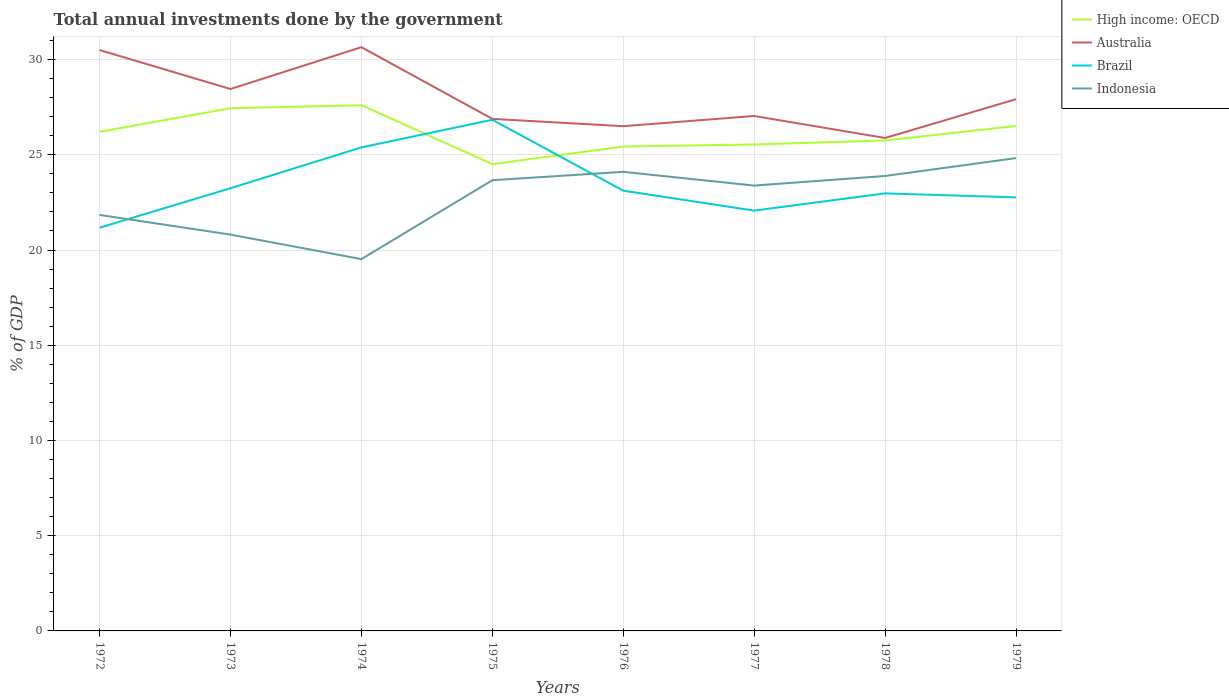How many different coloured lines are there?
Your answer should be compact. 4. Across all years, what is the maximum total annual investments done by the government in Indonesia?
Ensure brevity in your answer.  19.52. In which year was the total annual investments done by the government in High income: OECD maximum?
Provide a short and direct response. 1975. What is the total total annual investments done by the government in Australia in the graph?
Ensure brevity in your answer.  -2.2. What is the difference between the highest and the second highest total annual investments done by the government in Indonesia?
Provide a succinct answer. 5.3. Is the total annual investments done by the government in Australia strictly greater than the total annual investments done by the government in Indonesia over the years?
Your answer should be very brief. No. How many lines are there?
Offer a terse response. 4. What is the difference between two consecutive major ticks on the Y-axis?
Ensure brevity in your answer.  5. Does the graph contain grids?
Give a very brief answer. Yes. How many legend labels are there?
Offer a terse response. 4. How are the legend labels stacked?
Provide a succinct answer. Vertical. What is the title of the graph?
Your response must be concise. Total annual investments done by the government. What is the label or title of the Y-axis?
Give a very brief answer. % of GDP. What is the % of GDP of High income: OECD in 1972?
Keep it short and to the point. 26.21. What is the % of GDP in Australia in 1972?
Ensure brevity in your answer.  30.5. What is the % of GDP in Brazil in 1972?
Provide a short and direct response. 21.17. What is the % of GDP of Indonesia in 1972?
Your answer should be compact. 21.84. What is the % of GDP in High income: OECD in 1973?
Keep it short and to the point. 27.45. What is the % of GDP in Australia in 1973?
Give a very brief answer. 28.45. What is the % of GDP of Brazil in 1973?
Your response must be concise. 23.24. What is the % of GDP in Indonesia in 1973?
Ensure brevity in your answer.  20.81. What is the % of GDP of High income: OECD in 1974?
Offer a very short reply. 27.6. What is the % of GDP in Australia in 1974?
Ensure brevity in your answer.  30.65. What is the % of GDP in Brazil in 1974?
Your answer should be compact. 25.39. What is the % of GDP of Indonesia in 1974?
Make the answer very short. 19.52. What is the % of GDP in High income: OECD in 1975?
Give a very brief answer. 24.51. What is the % of GDP in Australia in 1975?
Provide a succinct answer. 26.89. What is the % of GDP in Brazil in 1975?
Keep it short and to the point. 26.84. What is the % of GDP of Indonesia in 1975?
Keep it short and to the point. 23.66. What is the % of GDP of High income: OECD in 1976?
Your response must be concise. 25.43. What is the % of GDP in Australia in 1976?
Give a very brief answer. 26.5. What is the % of GDP of Brazil in 1976?
Make the answer very short. 23.12. What is the % of GDP in Indonesia in 1976?
Your response must be concise. 24.1. What is the % of GDP in High income: OECD in 1977?
Provide a succinct answer. 25.54. What is the % of GDP in Australia in 1977?
Your response must be concise. 27.04. What is the % of GDP of Brazil in 1977?
Your answer should be very brief. 22.07. What is the % of GDP of Indonesia in 1977?
Offer a terse response. 23.38. What is the % of GDP of High income: OECD in 1978?
Give a very brief answer. 25.75. What is the % of GDP in Australia in 1978?
Keep it short and to the point. 25.88. What is the % of GDP in Brazil in 1978?
Give a very brief answer. 22.97. What is the % of GDP in Indonesia in 1978?
Offer a very short reply. 23.89. What is the % of GDP of High income: OECD in 1979?
Give a very brief answer. 26.51. What is the % of GDP of Australia in 1979?
Ensure brevity in your answer.  27.92. What is the % of GDP in Brazil in 1979?
Offer a terse response. 22.76. What is the % of GDP in Indonesia in 1979?
Provide a short and direct response. 24.83. Across all years, what is the maximum % of GDP of High income: OECD?
Keep it short and to the point. 27.6. Across all years, what is the maximum % of GDP of Australia?
Keep it short and to the point. 30.65. Across all years, what is the maximum % of GDP in Brazil?
Your response must be concise. 26.84. Across all years, what is the maximum % of GDP of Indonesia?
Your response must be concise. 24.83. Across all years, what is the minimum % of GDP in High income: OECD?
Your answer should be very brief. 24.51. Across all years, what is the minimum % of GDP in Australia?
Provide a succinct answer. 25.88. Across all years, what is the minimum % of GDP of Brazil?
Your response must be concise. 21.17. Across all years, what is the minimum % of GDP of Indonesia?
Your answer should be compact. 19.52. What is the total % of GDP of High income: OECD in the graph?
Your response must be concise. 209.01. What is the total % of GDP in Australia in the graph?
Offer a very short reply. 223.83. What is the total % of GDP of Brazil in the graph?
Ensure brevity in your answer.  187.57. What is the total % of GDP of Indonesia in the graph?
Make the answer very short. 182.04. What is the difference between the % of GDP of High income: OECD in 1972 and that in 1973?
Provide a succinct answer. -1.24. What is the difference between the % of GDP of Australia in 1972 and that in 1973?
Provide a succinct answer. 2.05. What is the difference between the % of GDP in Brazil in 1972 and that in 1973?
Ensure brevity in your answer.  -2.07. What is the difference between the % of GDP in Indonesia in 1972 and that in 1973?
Provide a succinct answer. 1.03. What is the difference between the % of GDP in High income: OECD in 1972 and that in 1974?
Ensure brevity in your answer.  -1.39. What is the difference between the % of GDP in Australia in 1972 and that in 1974?
Offer a very short reply. -0.15. What is the difference between the % of GDP of Brazil in 1972 and that in 1974?
Make the answer very short. -4.22. What is the difference between the % of GDP of Indonesia in 1972 and that in 1974?
Your response must be concise. 2.32. What is the difference between the % of GDP of High income: OECD in 1972 and that in 1975?
Provide a short and direct response. 1.7. What is the difference between the % of GDP of Australia in 1972 and that in 1975?
Your response must be concise. 3.62. What is the difference between the % of GDP in Brazil in 1972 and that in 1975?
Give a very brief answer. -5.67. What is the difference between the % of GDP of Indonesia in 1972 and that in 1975?
Offer a terse response. -1.82. What is the difference between the % of GDP in High income: OECD in 1972 and that in 1976?
Your answer should be compact. 0.77. What is the difference between the % of GDP of Australia in 1972 and that in 1976?
Your answer should be compact. 4. What is the difference between the % of GDP in Brazil in 1972 and that in 1976?
Provide a short and direct response. -1.95. What is the difference between the % of GDP in Indonesia in 1972 and that in 1976?
Keep it short and to the point. -2.26. What is the difference between the % of GDP in High income: OECD in 1972 and that in 1977?
Keep it short and to the point. 0.67. What is the difference between the % of GDP of Australia in 1972 and that in 1977?
Your answer should be very brief. 3.46. What is the difference between the % of GDP of Brazil in 1972 and that in 1977?
Your answer should be compact. -0.9. What is the difference between the % of GDP in Indonesia in 1972 and that in 1977?
Give a very brief answer. -1.54. What is the difference between the % of GDP in High income: OECD in 1972 and that in 1978?
Provide a short and direct response. 0.46. What is the difference between the % of GDP of Australia in 1972 and that in 1978?
Provide a short and direct response. 4.62. What is the difference between the % of GDP of Brazil in 1972 and that in 1978?
Keep it short and to the point. -1.8. What is the difference between the % of GDP in Indonesia in 1972 and that in 1978?
Your answer should be compact. -2.05. What is the difference between the % of GDP in High income: OECD in 1972 and that in 1979?
Ensure brevity in your answer.  -0.31. What is the difference between the % of GDP of Australia in 1972 and that in 1979?
Offer a terse response. 2.58. What is the difference between the % of GDP of Brazil in 1972 and that in 1979?
Offer a very short reply. -1.59. What is the difference between the % of GDP in Indonesia in 1972 and that in 1979?
Make the answer very short. -2.98. What is the difference between the % of GDP of High income: OECD in 1973 and that in 1974?
Offer a very short reply. -0.16. What is the difference between the % of GDP in Australia in 1973 and that in 1974?
Your response must be concise. -2.2. What is the difference between the % of GDP of Brazil in 1973 and that in 1974?
Offer a very short reply. -2.14. What is the difference between the % of GDP of Indonesia in 1973 and that in 1974?
Your answer should be compact. 1.29. What is the difference between the % of GDP in High income: OECD in 1973 and that in 1975?
Offer a very short reply. 2.94. What is the difference between the % of GDP of Australia in 1973 and that in 1975?
Offer a very short reply. 1.57. What is the difference between the % of GDP of Brazil in 1973 and that in 1975?
Offer a very short reply. -3.59. What is the difference between the % of GDP of Indonesia in 1973 and that in 1975?
Keep it short and to the point. -2.86. What is the difference between the % of GDP of High income: OECD in 1973 and that in 1976?
Your answer should be very brief. 2.01. What is the difference between the % of GDP of Australia in 1973 and that in 1976?
Offer a very short reply. 1.95. What is the difference between the % of GDP in Brazil in 1973 and that in 1976?
Provide a succinct answer. 0.13. What is the difference between the % of GDP in Indonesia in 1973 and that in 1976?
Give a very brief answer. -3.3. What is the difference between the % of GDP of High income: OECD in 1973 and that in 1977?
Your answer should be very brief. 1.91. What is the difference between the % of GDP of Australia in 1973 and that in 1977?
Your answer should be very brief. 1.42. What is the difference between the % of GDP in Brazil in 1973 and that in 1977?
Your response must be concise. 1.17. What is the difference between the % of GDP of Indonesia in 1973 and that in 1977?
Your answer should be very brief. -2.58. What is the difference between the % of GDP in High income: OECD in 1973 and that in 1978?
Offer a terse response. 1.69. What is the difference between the % of GDP of Australia in 1973 and that in 1978?
Keep it short and to the point. 2.57. What is the difference between the % of GDP in Brazil in 1973 and that in 1978?
Ensure brevity in your answer.  0.27. What is the difference between the % of GDP in Indonesia in 1973 and that in 1978?
Your response must be concise. -3.08. What is the difference between the % of GDP in High income: OECD in 1973 and that in 1979?
Ensure brevity in your answer.  0.93. What is the difference between the % of GDP in Australia in 1973 and that in 1979?
Your response must be concise. 0.53. What is the difference between the % of GDP in Brazil in 1973 and that in 1979?
Your answer should be compact. 0.48. What is the difference between the % of GDP of Indonesia in 1973 and that in 1979?
Give a very brief answer. -4.02. What is the difference between the % of GDP in High income: OECD in 1974 and that in 1975?
Give a very brief answer. 3.09. What is the difference between the % of GDP of Australia in 1974 and that in 1975?
Keep it short and to the point. 3.76. What is the difference between the % of GDP in Brazil in 1974 and that in 1975?
Your answer should be very brief. -1.45. What is the difference between the % of GDP of Indonesia in 1974 and that in 1975?
Offer a terse response. -4.14. What is the difference between the % of GDP of High income: OECD in 1974 and that in 1976?
Keep it short and to the point. 2.17. What is the difference between the % of GDP of Australia in 1974 and that in 1976?
Keep it short and to the point. 4.15. What is the difference between the % of GDP in Brazil in 1974 and that in 1976?
Offer a terse response. 2.27. What is the difference between the % of GDP in Indonesia in 1974 and that in 1976?
Offer a terse response. -4.58. What is the difference between the % of GDP of High income: OECD in 1974 and that in 1977?
Make the answer very short. 2.06. What is the difference between the % of GDP in Australia in 1974 and that in 1977?
Provide a short and direct response. 3.61. What is the difference between the % of GDP in Brazil in 1974 and that in 1977?
Your answer should be very brief. 3.32. What is the difference between the % of GDP of Indonesia in 1974 and that in 1977?
Provide a succinct answer. -3.86. What is the difference between the % of GDP in High income: OECD in 1974 and that in 1978?
Your answer should be compact. 1.85. What is the difference between the % of GDP in Australia in 1974 and that in 1978?
Offer a terse response. 4.77. What is the difference between the % of GDP of Brazil in 1974 and that in 1978?
Your response must be concise. 2.42. What is the difference between the % of GDP in Indonesia in 1974 and that in 1978?
Provide a succinct answer. -4.37. What is the difference between the % of GDP in High income: OECD in 1974 and that in 1979?
Offer a terse response. 1.09. What is the difference between the % of GDP of Australia in 1974 and that in 1979?
Your answer should be very brief. 2.73. What is the difference between the % of GDP in Brazil in 1974 and that in 1979?
Make the answer very short. 2.62. What is the difference between the % of GDP in Indonesia in 1974 and that in 1979?
Provide a succinct answer. -5.3. What is the difference between the % of GDP of High income: OECD in 1975 and that in 1976?
Your answer should be very brief. -0.93. What is the difference between the % of GDP in Australia in 1975 and that in 1976?
Keep it short and to the point. 0.38. What is the difference between the % of GDP in Brazil in 1975 and that in 1976?
Your answer should be compact. 3.72. What is the difference between the % of GDP in Indonesia in 1975 and that in 1976?
Offer a terse response. -0.44. What is the difference between the % of GDP in High income: OECD in 1975 and that in 1977?
Provide a succinct answer. -1.03. What is the difference between the % of GDP in Australia in 1975 and that in 1977?
Provide a succinct answer. -0.15. What is the difference between the % of GDP in Brazil in 1975 and that in 1977?
Your answer should be compact. 4.77. What is the difference between the % of GDP in Indonesia in 1975 and that in 1977?
Make the answer very short. 0.28. What is the difference between the % of GDP of High income: OECD in 1975 and that in 1978?
Ensure brevity in your answer.  -1.24. What is the difference between the % of GDP of Australia in 1975 and that in 1978?
Offer a terse response. 1. What is the difference between the % of GDP in Brazil in 1975 and that in 1978?
Your answer should be very brief. 3.87. What is the difference between the % of GDP in Indonesia in 1975 and that in 1978?
Your answer should be compact. -0.22. What is the difference between the % of GDP in High income: OECD in 1975 and that in 1979?
Make the answer very short. -2.01. What is the difference between the % of GDP in Australia in 1975 and that in 1979?
Offer a terse response. -1.03. What is the difference between the % of GDP in Brazil in 1975 and that in 1979?
Your answer should be compact. 4.07. What is the difference between the % of GDP of Indonesia in 1975 and that in 1979?
Keep it short and to the point. -1.16. What is the difference between the % of GDP of High income: OECD in 1976 and that in 1977?
Provide a short and direct response. -0.11. What is the difference between the % of GDP in Australia in 1976 and that in 1977?
Keep it short and to the point. -0.54. What is the difference between the % of GDP of Brazil in 1976 and that in 1977?
Keep it short and to the point. 1.05. What is the difference between the % of GDP in Indonesia in 1976 and that in 1977?
Give a very brief answer. 0.72. What is the difference between the % of GDP of High income: OECD in 1976 and that in 1978?
Give a very brief answer. -0.32. What is the difference between the % of GDP of Australia in 1976 and that in 1978?
Offer a terse response. 0.62. What is the difference between the % of GDP of Brazil in 1976 and that in 1978?
Your response must be concise. 0.14. What is the difference between the % of GDP of Indonesia in 1976 and that in 1978?
Offer a terse response. 0.22. What is the difference between the % of GDP in High income: OECD in 1976 and that in 1979?
Keep it short and to the point. -1.08. What is the difference between the % of GDP of Australia in 1976 and that in 1979?
Offer a terse response. -1.42. What is the difference between the % of GDP of Brazil in 1976 and that in 1979?
Provide a succinct answer. 0.35. What is the difference between the % of GDP in Indonesia in 1976 and that in 1979?
Keep it short and to the point. -0.72. What is the difference between the % of GDP of High income: OECD in 1977 and that in 1978?
Your answer should be very brief. -0.21. What is the difference between the % of GDP of Australia in 1977 and that in 1978?
Keep it short and to the point. 1.15. What is the difference between the % of GDP of Brazil in 1977 and that in 1978?
Offer a very short reply. -0.9. What is the difference between the % of GDP of Indonesia in 1977 and that in 1978?
Provide a succinct answer. -0.5. What is the difference between the % of GDP of High income: OECD in 1977 and that in 1979?
Keep it short and to the point. -0.97. What is the difference between the % of GDP in Australia in 1977 and that in 1979?
Provide a succinct answer. -0.88. What is the difference between the % of GDP of Brazil in 1977 and that in 1979?
Make the answer very short. -0.7. What is the difference between the % of GDP in Indonesia in 1977 and that in 1979?
Offer a terse response. -1.44. What is the difference between the % of GDP in High income: OECD in 1978 and that in 1979?
Offer a very short reply. -0.76. What is the difference between the % of GDP of Australia in 1978 and that in 1979?
Offer a very short reply. -2.04. What is the difference between the % of GDP of Brazil in 1978 and that in 1979?
Your answer should be compact. 0.21. What is the difference between the % of GDP in Indonesia in 1978 and that in 1979?
Give a very brief answer. -0.94. What is the difference between the % of GDP in High income: OECD in 1972 and the % of GDP in Australia in 1973?
Your answer should be compact. -2.24. What is the difference between the % of GDP in High income: OECD in 1972 and the % of GDP in Brazil in 1973?
Keep it short and to the point. 2.96. What is the difference between the % of GDP of High income: OECD in 1972 and the % of GDP of Indonesia in 1973?
Provide a succinct answer. 5.4. What is the difference between the % of GDP of Australia in 1972 and the % of GDP of Brazil in 1973?
Provide a succinct answer. 7.26. What is the difference between the % of GDP in Australia in 1972 and the % of GDP in Indonesia in 1973?
Provide a succinct answer. 9.69. What is the difference between the % of GDP of Brazil in 1972 and the % of GDP of Indonesia in 1973?
Offer a terse response. 0.36. What is the difference between the % of GDP of High income: OECD in 1972 and the % of GDP of Australia in 1974?
Your response must be concise. -4.44. What is the difference between the % of GDP of High income: OECD in 1972 and the % of GDP of Brazil in 1974?
Provide a short and direct response. 0.82. What is the difference between the % of GDP of High income: OECD in 1972 and the % of GDP of Indonesia in 1974?
Your answer should be very brief. 6.69. What is the difference between the % of GDP in Australia in 1972 and the % of GDP in Brazil in 1974?
Make the answer very short. 5.11. What is the difference between the % of GDP in Australia in 1972 and the % of GDP in Indonesia in 1974?
Offer a very short reply. 10.98. What is the difference between the % of GDP of Brazil in 1972 and the % of GDP of Indonesia in 1974?
Offer a terse response. 1.65. What is the difference between the % of GDP of High income: OECD in 1972 and the % of GDP of Australia in 1975?
Your answer should be very brief. -0.68. What is the difference between the % of GDP in High income: OECD in 1972 and the % of GDP in Brazil in 1975?
Provide a short and direct response. -0.63. What is the difference between the % of GDP of High income: OECD in 1972 and the % of GDP of Indonesia in 1975?
Offer a very short reply. 2.54. What is the difference between the % of GDP of Australia in 1972 and the % of GDP of Brazil in 1975?
Provide a succinct answer. 3.66. What is the difference between the % of GDP in Australia in 1972 and the % of GDP in Indonesia in 1975?
Ensure brevity in your answer.  6.84. What is the difference between the % of GDP of Brazil in 1972 and the % of GDP of Indonesia in 1975?
Your response must be concise. -2.49. What is the difference between the % of GDP in High income: OECD in 1972 and the % of GDP in Australia in 1976?
Give a very brief answer. -0.29. What is the difference between the % of GDP of High income: OECD in 1972 and the % of GDP of Brazil in 1976?
Offer a very short reply. 3.09. What is the difference between the % of GDP of High income: OECD in 1972 and the % of GDP of Indonesia in 1976?
Give a very brief answer. 2.1. What is the difference between the % of GDP in Australia in 1972 and the % of GDP in Brazil in 1976?
Your answer should be compact. 7.38. What is the difference between the % of GDP in Australia in 1972 and the % of GDP in Indonesia in 1976?
Make the answer very short. 6.4. What is the difference between the % of GDP in Brazil in 1972 and the % of GDP in Indonesia in 1976?
Keep it short and to the point. -2.93. What is the difference between the % of GDP in High income: OECD in 1972 and the % of GDP in Australia in 1977?
Keep it short and to the point. -0.83. What is the difference between the % of GDP in High income: OECD in 1972 and the % of GDP in Brazil in 1977?
Your answer should be compact. 4.14. What is the difference between the % of GDP of High income: OECD in 1972 and the % of GDP of Indonesia in 1977?
Ensure brevity in your answer.  2.83. What is the difference between the % of GDP in Australia in 1972 and the % of GDP in Brazil in 1977?
Your answer should be compact. 8.43. What is the difference between the % of GDP in Australia in 1972 and the % of GDP in Indonesia in 1977?
Offer a terse response. 7.12. What is the difference between the % of GDP of Brazil in 1972 and the % of GDP of Indonesia in 1977?
Your response must be concise. -2.21. What is the difference between the % of GDP of High income: OECD in 1972 and the % of GDP of Australia in 1978?
Give a very brief answer. 0.33. What is the difference between the % of GDP of High income: OECD in 1972 and the % of GDP of Brazil in 1978?
Give a very brief answer. 3.24. What is the difference between the % of GDP in High income: OECD in 1972 and the % of GDP in Indonesia in 1978?
Your answer should be compact. 2.32. What is the difference between the % of GDP of Australia in 1972 and the % of GDP of Brazil in 1978?
Keep it short and to the point. 7.53. What is the difference between the % of GDP of Australia in 1972 and the % of GDP of Indonesia in 1978?
Provide a short and direct response. 6.61. What is the difference between the % of GDP of Brazil in 1972 and the % of GDP of Indonesia in 1978?
Your answer should be very brief. -2.72. What is the difference between the % of GDP of High income: OECD in 1972 and the % of GDP of Australia in 1979?
Ensure brevity in your answer.  -1.71. What is the difference between the % of GDP of High income: OECD in 1972 and the % of GDP of Brazil in 1979?
Your answer should be compact. 3.44. What is the difference between the % of GDP of High income: OECD in 1972 and the % of GDP of Indonesia in 1979?
Provide a short and direct response. 1.38. What is the difference between the % of GDP of Australia in 1972 and the % of GDP of Brazil in 1979?
Offer a very short reply. 7.74. What is the difference between the % of GDP in Australia in 1972 and the % of GDP in Indonesia in 1979?
Provide a succinct answer. 5.67. What is the difference between the % of GDP of Brazil in 1972 and the % of GDP of Indonesia in 1979?
Your response must be concise. -3.66. What is the difference between the % of GDP of High income: OECD in 1973 and the % of GDP of Australia in 1974?
Ensure brevity in your answer.  -3.2. What is the difference between the % of GDP of High income: OECD in 1973 and the % of GDP of Brazil in 1974?
Offer a very short reply. 2.06. What is the difference between the % of GDP in High income: OECD in 1973 and the % of GDP in Indonesia in 1974?
Your answer should be compact. 7.93. What is the difference between the % of GDP of Australia in 1973 and the % of GDP of Brazil in 1974?
Make the answer very short. 3.06. What is the difference between the % of GDP in Australia in 1973 and the % of GDP in Indonesia in 1974?
Make the answer very short. 8.93. What is the difference between the % of GDP of Brazil in 1973 and the % of GDP of Indonesia in 1974?
Ensure brevity in your answer.  3.72. What is the difference between the % of GDP of High income: OECD in 1973 and the % of GDP of Australia in 1975?
Offer a very short reply. 0.56. What is the difference between the % of GDP of High income: OECD in 1973 and the % of GDP of Brazil in 1975?
Your answer should be very brief. 0.61. What is the difference between the % of GDP of High income: OECD in 1973 and the % of GDP of Indonesia in 1975?
Provide a short and direct response. 3.78. What is the difference between the % of GDP of Australia in 1973 and the % of GDP of Brazil in 1975?
Your answer should be very brief. 1.61. What is the difference between the % of GDP in Australia in 1973 and the % of GDP in Indonesia in 1975?
Provide a succinct answer. 4.79. What is the difference between the % of GDP of Brazil in 1973 and the % of GDP of Indonesia in 1975?
Your answer should be very brief. -0.42. What is the difference between the % of GDP in High income: OECD in 1973 and the % of GDP in Australia in 1976?
Ensure brevity in your answer.  0.95. What is the difference between the % of GDP in High income: OECD in 1973 and the % of GDP in Brazil in 1976?
Ensure brevity in your answer.  4.33. What is the difference between the % of GDP of High income: OECD in 1973 and the % of GDP of Indonesia in 1976?
Give a very brief answer. 3.34. What is the difference between the % of GDP of Australia in 1973 and the % of GDP of Brazil in 1976?
Your response must be concise. 5.34. What is the difference between the % of GDP of Australia in 1973 and the % of GDP of Indonesia in 1976?
Your response must be concise. 4.35. What is the difference between the % of GDP in Brazil in 1973 and the % of GDP in Indonesia in 1976?
Keep it short and to the point. -0.86. What is the difference between the % of GDP of High income: OECD in 1973 and the % of GDP of Australia in 1977?
Give a very brief answer. 0.41. What is the difference between the % of GDP in High income: OECD in 1973 and the % of GDP in Brazil in 1977?
Your answer should be compact. 5.38. What is the difference between the % of GDP in High income: OECD in 1973 and the % of GDP in Indonesia in 1977?
Provide a succinct answer. 4.06. What is the difference between the % of GDP in Australia in 1973 and the % of GDP in Brazil in 1977?
Your answer should be compact. 6.38. What is the difference between the % of GDP in Australia in 1973 and the % of GDP in Indonesia in 1977?
Provide a succinct answer. 5.07. What is the difference between the % of GDP in Brazil in 1973 and the % of GDP in Indonesia in 1977?
Keep it short and to the point. -0.14. What is the difference between the % of GDP of High income: OECD in 1973 and the % of GDP of Australia in 1978?
Offer a very short reply. 1.56. What is the difference between the % of GDP of High income: OECD in 1973 and the % of GDP of Brazil in 1978?
Provide a succinct answer. 4.47. What is the difference between the % of GDP in High income: OECD in 1973 and the % of GDP in Indonesia in 1978?
Keep it short and to the point. 3.56. What is the difference between the % of GDP of Australia in 1973 and the % of GDP of Brazil in 1978?
Provide a succinct answer. 5.48. What is the difference between the % of GDP in Australia in 1973 and the % of GDP in Indonesia in 1978?
Your response must be concise. 4.57. What is the difference between the % of GDP in Brazil in 1973 and the % of GDP in Indonesia in 1978?
Make the answer very short. -0.64. What is the difference between the % of GDP in High income: OECD in 1973 and the % of GDP in Australia in 1979?
Your answer should be very brief. -0.47. What is the difference between the % of GDP of High income: OECD in 1973 and the % of GDP of Brazil in 1979?
Provide a short and direct response. 4.68. What is the difference between the % of GDP in High income: OECD in 1973 and the % of GDP in Indonesia in 1979?
Give a very brief answer. 2.62. What is the difference between the % of GDP in Australia in 1973 and the % of GDP in Brazil in 1979?
Provide a short and direct response. 5.69. What is the difference between the % of GDP in Australia in 1973 and the % of GDP in Indonesia in 1979?
Make the answer very short. 3.63. What is the difference between the % of GDP in Brazil in 1973 and the % of GDP in Indonesia in 1979?
Offer a very short reply. -1.58. What is the difference between the % of GDP in High income: OECD in 1974 and the % of GDP in Australia in 1975?
Keep it short and to the point. 0.72. What is the difference between the % of GDP of High income: OECD in 1974 and the % of GDP of Brazil in 1975?
Your answer should be very brief. 0.76. What is the difference between the % of GDP of High income: OECD in 1974 and the % of GDP of Indonesia in 1975?
Provide a short and direct response. 3.94. What is the difference between the % of GDP of Australia in 1974 and the % of GDP of Brazil in 1975?
Your answer should be very brief. 3.81. What is the difference between the % of GDP of Australia in 1974 and the % of GDP of Indonesia in 1975?
Provide a succinct answer. 6.99. What is the difference between the % of GDP in Brazil in 1974 and the % of GDP in Indonesia in 1975?
Your answer should be compact. 1.72. What is the difference between the % of GDP of High income: OECD in 1974 and the % of GDP of Australia in 1976?
Provide a succinct answer. 1.1. What is the difference between the % of GDP in High income: OECD in 1974 and the % of GDP in Brazil in 1976?
Your answer should be compact. 4.49. What is the difference between the % of GDP in High income: OECD in 1974 and the % of GDP in Indonesia in 1976?
Your response must be concise. 3.5. What is the difference between the % of GDP in Australia in 1974 and the % of GDP in Brazil in 1976?
Provide a short and direct response. 7.53. What is the difference between the % of GDP in Australia in 1974 and the % of GDP in Indonesia in 1976?
Your answer should be very brief. 6.55. What is the difference between the % of GDP in Brazil in 1974 and the % of GDP in Indonesia in 1976?
Offer a terse response. 1.28. What is the difference between the % of GDP of High income: OECD in 1974 and the % of GDP of Australia in 1977?
Offer a terse response. 0.57. What is the difference between the % of GDP of High income: OECD in 1974 and the % of GDP of Brazil in 1977?
Provide a succinct answer. 5.53. What is the difference between the % of GDP in High income: OECD in 1974 and the % of GDP in Indonesia in 1977?
Your response must be concise. 4.22. What is the difference between the % of GDP in Australia in 1974 and the % of GDP in Brazil in 1977?
Give a very brief answer. 8.58. What is the difference between the % of GDP in Australia in 1974 and the % of GDP in Indonesia in 1977?
Make the answer very short. 7.27. What is the difference between the % of GDP in Brazil in 1974 and the % of GDP in Indonesia in 1977?
Give a very brief answer. 2. What is the difference between the % of GDP in High income: OECD in 1974 and the % of GDP in Australia in 1978?
Offer a terse response. 1.72. What is the difference between the % of GDP in High income: OECD in 1974 and the % of GDP in Brazil in 1978?
Ensure brevity in your answer.  4.63. What is the difference between the % of GDP in High income: OECD in 1974 and the % of GDP in Indonesia in 1978?
Give a very brief answer. 3.71. What is the difference between the % of GDP of Australia in 1974 and the % of GDP of Brazil in 1978?
Ensure brevity in your answer.  7.68. What is the difference between the % of GDP of Australia in 1974 and the % of GDP of Indonesia in 1978?
Your answer should be compact. 6.76. What is the difference between the % of GDP in Brazil in 1974 and the % of GDP in Indonesia in 1978?
Give a very brief answer. 1.5. What is the difference between the % of GDP in High income: OECD in 1974 and the % of GDP in Australia in 1979?
Provide a short and direct response. -0.32. What is the difference between the % of GDP in High income: OECD in 1974 and the % of GDP in Brazil in 1979?
Offer a very short reply. 4.84. What is the difference between the % of GDP in High income: OECD in 1974 and the % of GDP in Indonesia in 1979?
Make the answer very short. 2.78. What is the difference between the % of GDP in Australia in 1974 and the % of GDP in Brazil in 1979?
Your answer should be compact. 7.89. What is the difference between the % of GDP of Australia in 1974 and the % of GDP of Indonesia in 1979?
Offer a terse response. 5.82. What is the difference between the % of GDP of Brazil in 1974 and the % of GDP of Indonesia in 1979?
Make the answer very short. 0.56. What is the difference between the % of GDP of High income: OECD in 1975 and the % of GDP of Australia in 1976?
Provide a succinct answer. -1.99. What is the difference between the % of GDP of High income: OECD in 1975 and the % of GDP of Brazil in 1976?
Offer a very short reply. 1.39. What is the difference between the % of GDP of High income: OECD in 1975 and the % of GDP of Indonesia in 1976?
Ensure brevity in your answer.  0.4. What is the difference between the % of GDP in Australia in 1975 and the % of GDP in Brazil in 1976?
Make the answer very short. 3.77. What is the difference between the % of GDP of Australia in 1975 and the % of GDP of Indonesia in 1976?
Offer a terse response. 2.78. What is the difference between the % of GDP in Brazil in 1975 and the % of GDP in Indonesia in 1976?
Your response must be concise. 2.73. What is the difference between the % of GDP in High income: OECD in 1975 and the % of GDP in Australia in 1977?
Your answer should be very brief. -2.53. What is the difference between the % of GDP of High income: OECD in 1975 and the % of GDP of Brazil in 1977?
Provide a succinct answer. 2.44. What is the difference between the % of GDP of High income: OECD in 1975 and the % of GDP of Indonesia in 1977?
Keep it short and to the point. 1.12. What is the difference between the % of GDP of Australia in 1975 and the % of GDP of Brazil in 1977?
Offer a terse response. 4.82. What is the difference between the % of GDP of Australia in 1975 and the % of GDP of Indonesia in 1977?
Provide a succinct answer. 3.5. What is the difference between the % of GDP of Brazil in 1975 and the % of GDP of Indonesia in 1977?
Give a very brief answer. 3.46. What is the difference between the % of GDP in High income: OECD in 1975 and the % of GDP in Australia in 1978?
Give a very brief answer. -1.37. What is the difference between the % of GDP of High income: OECD in 1975 and the % of GDP of Brazil in 1978?
Offer a terse response. 1.53. What is the difference between the % of GDP of High income: OECD in 1975 and the % of GDP of Indonesia in 1978?
Your response must be concise. 0.62. What is the difference between the % of GDP in Australia in 1975 and the % of GDP in Brazil in 1978?
Ensure brevity in your answer.  3.91. What is the difference between the % of GDP of Australia in 1975 and the % of GDP of Indonesia in 1978?
Make the answer very short. 3. What is the difference between the % of GDP in Brazil in 1975 and the % of GDP in Indonesia in 1978?
Your response must be concise. 2.95. What is the difference between the % of GDP in High income: OECD in 1975 and the % of GDP in Australia in 1979?
Your response must be concise. -3.41. What is the difference between the % of GDP in High income: OECD in 1975 and the % of GDP in Brazil in 1979?
Provide a succinct answer. 1.74. What is the difference between the % of GDP in High income: OECD in 1975 and the % of GDP in Indonesia in 1979?
Ensure brevity in your answer.  -0.32. What is the difference between the % of GDP in Australia in 1975 and the % of GDP in Brazil in 1979?
Offer a very short reply. 4.12. What is the difference between the % of GDP of Australia in 1975 and the % of GDP of Indonesia in 1979?
Ensure brevity in your answer.  2.06. What is the difference between the % of GDP of Brazil in 1975 and the % of GDP of Indonesia in 1979?
Give a very brief answer. 2.01. What is the difference between the % of GDP in High income: OECD in 1976 and the % of GDP in Australia in 1977?
Your response must be concise. -1.6. What is the difference between the % of GDP of High income: OECD in 1976 and the % of GDP of Brazil in 1977?
Offer a terse response. 3.37. What is the difference between the % of GDP in High income: OECD in 1976 and the % of GDP in Indonesia in 1977?
Ensure brevity in your answer.  2.05. What is the difference between the % of GDP in Australia in 1976 and the % of GDP in Brazil in 1977?
Your response must be concise. 4.43. What is the difference between the % of GDP of Australia in 1976 and the % of GDP of Indonesia in 1977?
Offer a very short reply. 3.12. What is the difference between the % of GDP in Brazil in 1976 and the % of GDP in Indonesia in 1977?
Provide a succinct answer. -0.27. What is the difference between the % of GDP of High income: OECD in 1976 and the % of GDP of Australia in 1978?
Offer a very short reply. -0.45. What is the difference between the % of GDP of High income: OECD in 1976 and the % of GDP of Brazil in 1978?
Ensure brevity in your answer.  2.46. What is the difference between the % of GDP of High income: OECD in 1976 and the % of GDP of Indonesia in 1978?
Ensure brevity in your answer.  1.55. What is the difference between the % of GDP of Australia in 1976 and the % of GDP of Brazil in 1978?
Your answer should be compact. 3.53. What is the difference between the % of GDP of Australia in 1976 and the % of GDP of Indonesia in 1978?
Your answer should be very brief. 2.61. What is the difference between the % of GDP of Brazil in 1976 and the % of GDP of Indonesia in 1978?
Provide a succinct answer. -0.77. What is the difference between the % of GDP of High income: OECD in 1976 and the % of GDP of Australia in 1979?
Ensure brevity in your answer.  -2.49. What is the difference between the % of GDP of High income: OECD in 1976 and the % of GDP of Brazil in 1979?
Keep it short and to the point. 2.67. What is the difference between the % of GDP in High income: OECD in 1976 and the % of GDP in Indonesia in 1979?
Provide a succinct answer. 0.61. What is the difference between the % of GDP of Australia in 1976 and the % of GDP of Brazil in 1979?
Your response must be concise. 3.74. What is the difference between the % of GDP in Australia in 1976 and the % of GDP in Indonesia in 1979?
Give a very brief answer. 1.68. What is the difference between the % of GDP in Brazil in 1976 and the % of GDP in Indonesia in 1979?
Make the answer very short. -1.71. What is the difference between the % of GDP in High income: OECD in 1977 and the % of GDP in Australia in 1978?
Your answer should be very brief. -0.34. What is the difference between the % of GDP in High income: OECD in 1977 and the % of GDP in Brazil in 1978?
Ensure brevity in your answer.  2.57. What is the difference between the % of GDP of High income: OECD in 1977 and the % of GDP of Indonesia in 1978?
Make the answer very short. 1.65. What is the difference between the % of GDP of Australia in 1977 and the % of GDP of Brazil in 1978?
Keep it short and to the point. 4.06. What is the difference between the % of GDP in Australia in 1977 and the % of GDP in Indonesia in 1978?
Your answer should be very brief. 3.15. What is the difference between the % of GDP in Brazil in 1977 and the % of GDP in Indonesia in 1978?
Your answer should be compact. -1.82. What is the difference between the % of GDP of High income: OECD in 1977 and the % of GDP of Australia in 1979?
Your response must be concise. -2.38. What is the difference between the % of GDP in High income: OECD in 1977 and the % of GDP in Brazil in 1979?
Offer a very short reply. 2.78. What is the difference between the % of GDP in High income: OECD in 1977 and the % of GDP in Indonesia in 1979?
Your answer should be very brief. 0.72. What is the difference between the % of GDP in Australia in 1977 and the % of GDP in Brazil in 1979?
Ensure brevity in your answer.  4.27. What is the difference between the % of GDP of Australia in 1977 and the % of GDP of Indonesia in 1979?
Offer a terse response. 2.21. What is the difference between the % of GDP in Brazil in 1977 and the % of GDP in Indonesia in 1979?
Your answer should be very brief. -2.76. What is the difference between the % of GDP of High income: OECD in 1978 and the % of GDP of Australia in 1979?
Provide a succinct answer. -2.17. What is the difference between the % of GDP in High income: OECD in 1978 and the % of GDP in Brazil in 1979?
Your answer should be compact. 2.99. What is the difference between the % of GDP in High income: OECD in 1978 and the % of GDP in Indonesia in 1979?
Keep it short and to the point. 0.93. What is the difference between the % of GDP of Australia in 1978 and the % of GDP of Brazil in 1979?
Ensure brevity in your answer.  3.12. What is the difference between the % of GDP in Australia in 1978 and the % of GDP in Indonesia in 1979?
Offer a very short reply. 1.06. What is the difference between the % of GDP of Brazil in 1978 and the % of GDP of Indonesia in 1979?
Provide a succinct answer. -1.85. What is the average % of GDP of High income: OECD per year?
Keep it short and to the point. 26.13. What is the average % of GDP of Australia per year?
Provide a succinct answer. 27.98. What is the average % of GDP of Brazil per year?
Your answer should be compact. 23.45. What is the average % of GDP of Indonesia per year?
Your answer should be very brief. 22.75. In the year 1972, what is the difference between the % of GDP in High income: OECD and % of GDP in Australia?
Ensure brevity in your answer.  -4.29. In the year 1972, what is the difference between the % of GDP in High income: OECD and % of GDP in Brazil?
Make the answer very short. 5.04. In the year 1972, what is the difference between the % of GDP in High income: OECD and % of GDP in Indonesia?
Make the answer very short. 4.37. In the year 1972, what is the difference between the % of GDP in Australia and % of GDP in Brazil?
Offer a very short reply. 9.33. In the year 1972, what is the difference between the % of GDP of Australia and % of GDP of Indonesia?
Keep it short and to the point. 8.66. In the year 1972, what is the difference between the % of GDP in Brazil and % of GDP in Indonesia?
Offer a terse response. -0.67. In the year 1973, what is the difference between the % of GDP of High income: OECD and % of GDP of Australia?
Keep it short and to the point. -1.01. In the year 1973, what is the difference between the % of GDP of High income: OECD and % of GDP of Brazil?
Offer a terse response. 4.2. In the year 1973, what is the difference between the % of GDP of High income: OECD and % of GDP of Indonesia?
Provide a succinct answer. 6.64. In the year 1973, what is the difference between the % of GDP of Australia and % of GDP of Brazil?
Make the answer very short. 5.21. In the year 1973, what is the difference between the % of GDP of Australia and % of GDP of Indonesia?
Your answer should be very brief. 7.64. In the year 1973, what is the difference between the % of GDP of Brazil and % of GDP of Indonesia?
Your answer should be very brief. 2.44. In the year 1974, what is the difference between the % of GDP of High income: OECD and % of GDP of Australia?
Provide a short and direct response. -3.05. In the year 1974, what is the difference between the % of GDP in High income: OECD and % of GDP in Brazil?
Offer a terse response. 2.21. In the year 1974, what is the difference between the % of GDP in High income: OECD and % of GDP in Indonesia?
Your answer should be compact. 8.08. In the year 1974, what is the difference between the % of GDP in Australia and % of GDP in Brazil?
Ensure brevity in your answer.  5.26. In the year 1974, what is the difference between the % of GDP of Australia and % of GDP of Indonesia?
Offer a terse response. 11.13. In the year 1974, what is the difference between the % of GDP in Brazil and % of GDP in Indonesia?
Keep it short and to the point. 5.87. In the year 1975, what is the difference between the % of GDP of High income: OECD and % of GDP of Australia?
Your answer should be compact. -2.38. In the year 1975, what is the difference between the % of GDP in High income: OECD and % of GDP in Brazil?
Offer a very short reply. -2.33. In the year 1975, what is the difference between the % of GDP of High income: OECD and % of GDP of Indonesia?
Your answer should be very brief. 0.84. In the year 1975, what is the difference between the % of GDP of Australia and % of GDP of Brazil?
Offer a very short reply. 0.05. In the year 1975, what is the difference between the % of GDP in Australia and % of GDP in Indonesia?
Your answer should be compact. 3.22. In the year 1975, what is the difference between the % of GDP in Brazil and % of GDP in Indonesia?
Provide a short and direct response. 3.17. In the year 1976, what is the difference between the % of GDP of High income: OECD and % of GDP of Australia?
Your response must be concise. -1.07. In the year 1976, what is the difference between the % of GDP of High income: OECD and % of GDP of Brazil?
Your response must be concise. 2.32. In the year 1976, what is the difference between the % of GDP in High income: OECD and % of GDP in Indonesia?
Provide a short and direct response. 1.33. In the year 1976, what is the difference between the % of GDP in Australia and % of GDP in Brazil?
Offer a very short reply. 3.39. In the year 1976, what is the difference between the % of GDP of Australia and % of GDP of Indonesia?
Provide a short and direct response. 2.4. In the year 1976, what is the difference between the % of GDP of Brazil and % of GDP of Indonesia?
Offer a terse response. -0.99. In the year 1977, what is the difference between the % of GDP in High income: OECD and % of GDP in Australia?
Your answer should be very brief. -1.5. In the year 1977, what is the difference between the % of GDP of High income: OECD and % of GDP of Brazil?
Offer a very short reply. 3.47. In the year 1977, what is the difference between the % of GDP of High income: OECD and % of GDP of Indonesia?
Your response must be concise. 2.16. In the year 1977, what is the difference between the % of GDP in Australia and % of GDP in Brazil?
Your answer should be compact. 4.97. In the year 1977, what is the difference between the % of GDP in Australia and % of GDP in Indonesia?
Make the answer very short. 3.65. In the year 1977, what is the difference between the % of GDP of Brazil and % of GDP of Indonesia?
Your answer should be compact. -1.31. In the year 1978, what is the difference between the % of GDP in High income: OECD and % of GDP in Australia?
Keep it short and to the point. -0.13. In the year 1978, what is the difference between the % of GDP of High income: OECD and % of GDP of Brazil?
Make the answer very short. 2.78. In the year 1978, what is the difference between the % of GDP of High income: OECD and % of GDP of Indonesia?
Your response must be concise. 1.86. In the year 1978, what is the difference between the % of GDP in Australia and % of GDP in Brazil?
Your response must be concise. 2.91. In the year 1978, what is the difference between the % of GDP of Australia and % of GDP of Indonesia?
Provide a succinct answer. 1.99. In the year 1978, what is the difference between the % of GDP of Brazil and % of GDP of Indonesia?
Provide a succinct answer. -0.91. In the year 1979, what is the difference between the % of GDP in High income: OECD and % of GDP in Australia?
Keep it short and to the point. -1.41. In the year 1979, what is the difference between the % of GDP in High income: OECD and % of GDP in Brazil?
Keep it short and to the point. 3.75. In the year 1979, what is the difference between the % of GDP of High income: OECD and % of GDP of Indonesia?
Make the answer very short. 1.69. In the year 1979, what is the difference between the % of GDP in Australia and % of GDP in Brazil?
Offer a terse response. 5.16. In the year 1979, what is the difference between the % of GDP in Australia and % of GDP in Indonesia?
Give a very brief answer. 3.09. In the year 1979, what is the difference between the % of GDP of Brazil and % of GDP of Indonesia?
Provide a short and direct response. -2.06. What is the ratio of the % of GDP of High income: OECD in 1972 to that in 1973?
Provide a succinct answer. 0.95. What is the ratio of the % of GDP of Australia in 1972 to that in 1973?
Offer a terse response. 1.07. What is the ratio of the % of GDP of Brazil in 1972 to that in 1973?
Provide a short and direct response. 0.91. What is the ratio of the % of GDP of Indonesia in 1972 to that in 1973?
Provide a short and direct response. 1.05. What is the ratio of the % of GDP of High income: OECD in 1972 to that in 1974?
Make the answer very short. 0.95. What is the ratio of the % of GDP of Brazil in 1972 to that in 1974?
Provide a succinct answer. 0.83. What is the ratio of the % of GDP of Indonesia in 1972 to that in 1974?
Offer a very short reply. 1.12. What is the ratio of the % of GDP in High income: OECD in 1972 to that in 1975?
Give a very brief answer. 1.07. What is the ratio of the % of GDP in Australia in 1972 to that in 1975?
Your answer should be very brief. 1.13. What is the ratio of the % of GDP of Brazil in 1972 to that in 1975?
Provide a succinct answer. 0.79. What is the ratio of the % of GDP of Indonesia in 1972 to that in 1975?
Offer a terse response. 0.92. What is the ratio of the % of GDP in High income: OECD in 1972 to that in 1976?
Ensure brevity in your answer.  1.03. What is the ratio of the % of GDP in Australia in 1972 to that in 1976?
Offer a terse response. 1.15. What is the ratio of the % of GDP of Brazil in 1972 to that in 1976?
Provide a short and direct response. 0.92. What is the ratio of the % of GDP of Indonesia in 1972 to that in 1976?
Your response must be concise. 0.91. What is the ratio of the % of GDP in High income: OECD in 1972 to that in 1977?
Your response must be concise. 1.03. What is the ratio of the % of GDP in Australia in 1972 to that in 1977?
Make the answer very short. 1.13. What is the ratio of the % of GDP of Brazil in 1972 to that in 1977?
Provide a succinct answer. 0.96. What is the ratio of the % of GDP in Indonesia in 1972 to that in 1977?
Provide a short and direct response. 0.93. What is the ratio of the % of GDP of High income: OECD in 1972 to that in 1978?
Your answer should be very brief. 1.02. What is the ratio of the % of GDP of Australia in 1972 to that in 1978?
Your answer should be very brief. 1.18. What is the ratio of the % of GDP in Brazil in 1972 to that in 1978?
Give a very brief answer. 0.92. What is the ratio of the % of GDP of Indonesia in 1972 to that in 1978?
Offer a very short reply. 0.91. What is the ratio of the % of GDP of High income: OECD in 1972 to that in 1979?
Make the answer very short. 0.99. What is the ratio of the % of GDP of Australia in 1972 to that in 1979?
Your response must be concise. 1.09. What is the ratio of the % of GDP of Brazil in 1972 to that in 1979?
Provide a short and direct response. 0.93. What is the ratio of the % of GDP of Indonesia in 1972 to that in 1979?
Offer a terse response. 0.88. What is the ratio of the % of GDP in Australia in 1973 to that in 1974?
Provide a succinct answer. 0.93. What is the ratio of the % of GDP in Brazil in 1973 to that in 1974?
Your answer should be compact. 0.92. What is the ratio of the % of GDP in Indonesia in 1973 to that in 1974?
Offer a very short reply. 1.07. What is the ratio of the % of GDP of High income: OECD in 1973 to that in 1975?
Provide a short and direct response. 1.12. What is the ratio of the % of GDP in Australia in 1973 to that in 1975?
Provide a succinct answer. 1.06. What is the ratio of the % of GDP in Brazil in 1973 to that in 1975?
Your answer should be very brief. 0.87. What is the ratio of the % of GDP in Indonesia in 1973 to that in 1975?
Your answer should be compact. 0.88. What is the ratio of the % of GDP of High income: OECD in 1973 to that in 1976?
Provide a succinct answer. 1.08. What is the ratio of the % of GDP in Australia in 1973 to that in 1976?
Your answer should be very brief. 1.07. What is the ratio of the % of GDP of Indonesia in 1973 to that in 1976?
Your response must be concise. 0.86. What is the ratio of the % of GDP in High income: OECD in 1973 to that in 1977?
Provide a short and direct response. 1.07. What is the ratio of the % of GDP in Australia in 1973 to that in 1977?
Provide a succinct answer. 1.05. What is the ratio of the % of GDP of Brazil in 1973 to that in 1977?
Your answer should be very brief. 1.05. What is the ratio of the % of GDP in Indonesia in 1973 to that in 1977?
Keep it short and to the point. 0.89. What is the ratio of the % of GDP of High income: OECD in 1973 to that in 1978?
Offer a very short reply. 1.07. What is the ratio of the % of GDP in Australia in 1973 to that in 1978?
Give a very brief answer. 1.1. What is the ratio of the % of GDP in Brazil in 1973 to that in 1978?
Your answer should be compact. 1.01. What is the ratio of the % of GDP in Indonesia in 1973 to that in 1978?
Provide a short and direct response. 0.87. What is the ratio of the % of GDP of High income: OECD in 1973 to that in 1979?
Provide a short and direct response. 1.04. What is the ratio of the % of GDP of Australia in 1973 to that in 1979?
Make the answer very short. 1.02. What is the ratio of the % of GDP of Brazil in 1973 to that in 1979?
Keep it short and to the point. 1.02. What is the ratio of the % of GDP in Indonesia in 1973 to that in 1979?
Offer a terse response. 0.84. What is the ratio of the % of GDP in High income: OECD in 1974 to that in 1975?
Keep it short and to the point. 1.13. What is the ratio of the % of GDP in Australia in 1974 to that in 1975?
Make the answer very short. 1.14. What is the ratio of the % of GDP in Brazil in 1974 to that in 1975?
Provide a short and direct response. 0.95. What is the ratio of the % of GDP of Indonesia in 1974 to that in 1975?
Offer a very short reply. 0.82. What is the ratio of the % of GDP of High income: OECD in 1974 to that in 1976?
Provide a short and direct response. 1.09. What is the ratio of the % of GDP in Australia in 1974 to that in 1976?
Give a very brief answer. 1.16. What is the ratio of the % of GDP in Brazil in 1974 to that in 1976?
Provide a succinct answer. 1.1. What is the ratio of the % of GDP in Indonesia in 1974 to that in 1976?
Your answer should be very brief. 0.81. What is the ratio of the % of GDP of High income: OECD in 1974 to that in 1977?
Your response must be concise. 1.08. What is the ratio of the % of GDP of Australia in 1974 to that in 1977?
Offer a terse response. 1.13. What is the ratio of the % of GDP in Brazil in 1974 to that in 1977?
Make the answer very short. 1.15. What is the ratio of the % of GDP of Indonesia in 1974 to that in 1977?
Offer a very short reply. 0.83. What is the ratio of the % of GDP of High income: OECD in 1974 to that in 1978?
Make the answer very short. 1.07. What is the ratio of the % of GDP of Australia in 1974 to that in 1978?
Offer a very short reply. 1.18. What is the ratio of the % of GDP in Brazil in 1974 to that in 1978?
Offer a terse response. 1.11. What is the ratio of the % of GDP in Indonesia in 1974 to that in 1978?
Offer a terse response. 0.82. What is the ratio of the % of GDP in High income: OECD in 1974 to that in 1979?
Keep it short and to the point. 1.04. What is the ratio of the % of GDP in Australia in 1974 to that in 1979?
Keep it short and to the point. 1.1. What is the ratio of the % of GDP in Brazil in 1974 to that in 1979?
Offer a very short reply. 1.12. What is the ratio of the % of GDP in Indonesia in 1974 to that in 1979?
Ensure brevity in your answer.  0.79. What is the ratio of the % of GDP of High income: OECD in 1975 to that in 1976?
Provide a short and direct response. 0.96. What is the ratio of the % of GDP in Australia in 1975 to that in 1976?
Keep it short and to the point. 1.01. What is the ratio of the % of GDP of Brazil in 1975 to that in 1976?
Ensure brevity in your answer.  1.16. What is the ratio of the % of GDP in Indonesia in 1975 to that in 1976?
Provide a short and direct response. 0.98. What is the ratio of the % of GDP of High income: OECD in 1975 to that in 1977?
Offer a terse response. 0.96. What is the ratio of the % of GDP of Australia in 1975 to that in 1977?
Keep it short and to the point. 0.99. What is the ratio of the % of GDP in Brazil in 1975 to that in 1977?
Provide a succinct answer. 1.22. What is the ratio of the % of GDP of High income: OECD in 1975 to that in 1978?
Offer a terse response. 0.95. What is the ratio of the % of GDP in Australia in 1975 to that in 1978?
Provide a short and direct response. 1.04. What is the ratio of the % of GDP of Brazil in 1975 to that in 1978?
Offer a terse response. 1.17. What is the ratio of the % of GDP in Indonesia in 1975 to that in 1978?
Your answer should be very brief. 0.99. What is the ratio of the % of GDP in High income: OECD in 1975 to that in 1979?
Give a very brief answer. 0.92. What is the ratio of the % of GDP in Brazil in 1975 to that in 1979?
Your answer should be compact. 1.18. What is the ratio of the % of GDP of Indonesia in 1975 to that in 1979?
Your answer should be very brief. 0.95. What is the ratio of the % of GDP in Australia in 1976 to that in 1977?
Keep it short and to the point. 0.98. What is the ratio of the % of GDP in Brazil in 1976 to that in 1977?
Provide a short and direct response. 1.05. What is the ratio of the % of GDP of Indonesia in 1976 to that in 1977?
Your answer should be compact. 1.03. What is the ratio of the % of GDP of High income: OECD in 1976 to that in 1978?
Make the answer very short. 0.99. What is the ratio of the % of GDP of Australia in 1976 to that in 1978?
Your answer should be compact. 1.02. What is the ratio of the % of GDP in Brazil in 1976 to that in 1978?
Offer a terse response. 1.01. What is the ratio of the % of GDP in Indonesia in 1976 to that in 1978?
Ensure brevity in your answer.  1.01. What is the ratio of the % of GDP in High income: OECD in 1976 to that in 1979?
Make the answer very short. 0.96. What is the ratio of the % of GDP of Australia in 1976 to that in 1979?
Your answer should be very brief. 0.95. What is the ratio of the % of GDP of Brazil in 1976 to that in 1979?
Offer a terse response. 1.02. What is the ratio of the % of GDP in Indonesia in 1976 to that in 1979?
Offer a very short reply. 0.97. What is the ratio of the % of GDP in Australia in 1977 to that in 1978?
Your answer should be very brief. 1.04. What is the ratio of the % of GDP of Brazil in 1977 to that in 1978?
Offer a terse response. 0.96. What is the ratio of the % of GDP of Indonesia in 1977 to that in 1978?
Provide a succinct answer. 0.98. What is the ratio of the % of GDP of High income: OECD in 1977 to that in 1979?
Ensure brevity in your answer.  0.96. What is the ratio of the % of GDP of Australia in 1977 to that in 1979?
Your answer should be very brief. 0.97. What is the ratio of the % of GDP in Brazil in 1977 to that in 1979?
Give a very brief answer. 0.97. What is the ratio of the % of GDP in Indonesia in 1977 to that in 1979?
Your answer should be very brief. 0.94. What is the ratio of the % of GDP of High income: OECD in 1978 to that in 1979?
Provide a succinct answer. 0.97. What is the ratio of the % of GDP in Australia in 1978 to that in 1979?
Your answer should be compact. 0.93. What is the ratio of the % of GDP in Brazil in 1978 to that in 1979?
Ensure brevity in your answer.  1.01. What is the ratio of the % of GDP of Indonesia in 1978 to that in 1979?
Offer a very short reply. 0.96. What is the difference between the highest and the second highest % of GDP in High income: OECD?
Ensure brevity in your answer.  0.16. What is the difference between the highest and the second highest % of GDP of Australia?
Make the answer very short. 0.15. What is the difference between the highest and the second highest % of GDP in Brazil?
Give a very brief answer. 1.45. What is the difference between the highest and the second highest % of GDP in Indonesia?
Give a very brief answer. 0.72. What is the difference between the highest and the lowest % of GDP of High income: OECD?
Ensure brevity in your answer.  3.09. What is the difference between the highest and the lowest % of GDP in Australia?
Provide a succinct answer. 4.77. What is the difference between the highest and the lowest % of GDP in Brazil?
Your answer should be compact. 5.67. What is the difference between the highest and the lowest % of GDP of Indonesia?
Your answer should be compact. 5.3. 